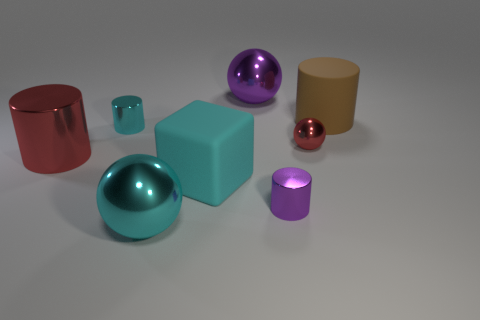How many rubber blocks are the same color as the large rubber cylinder?
Ensure brevity in your answer.  0. How many large cyan cubes are the same material as the large red object?
Your answer should be very brief. 0. How many objects are large red matte blocks or large matte things that are to the left of the big purple shiny ball?
Offer a terse response. 1. What color is the small thing that is to the right of the small cylinder to the right of the big rubber thing that is left of the small red sphere?
Offer a very short reply. Red. What size is the purple object that is behind the brown cylinder?
Your response must be concise. Large. How many small things are either cyan metallic spheres or cyan objects?
Offer a very short reply. 1. The object that is both in front of the red cylinder and right of the cyan rubber block is what color?
Provide a succinct answer. Purple. Is there a rubber object of the same shape as the small purple metal thing?
Your response must be concise. Yes. What material is the big block?
Your response must be concise. Rubber. Are there any cyan cylinders right of the cyan sphere?
Give a very brief answer. No. 